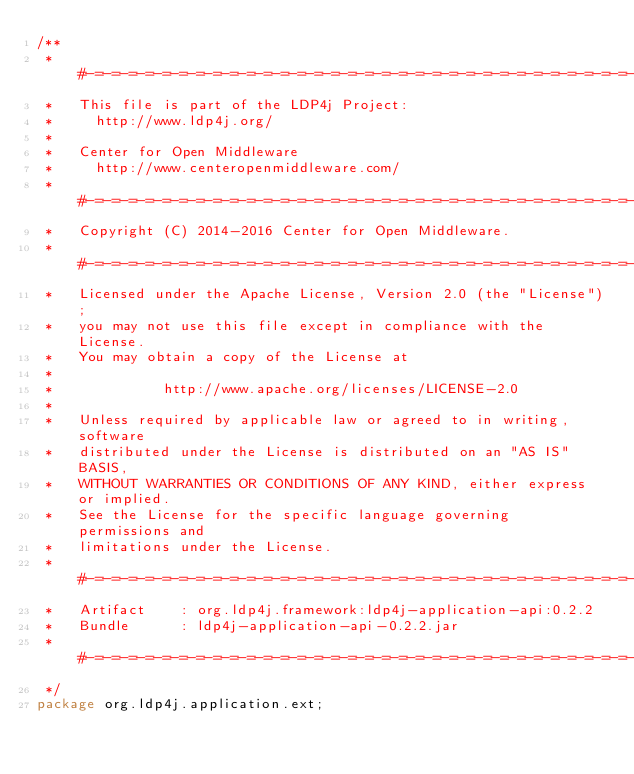Convert code to text. <code><loc_0><loc_0><loc_500><loc_500><_Java_>/**
 * #-=-=-=-=-=-=-=-=-=-=-=-=-=-=-=-=-=-=-=-=-=-=-=-=-=-=-=-=-=-=-=-=-=-=-=-=-=#
 *   This file is part of the LDP4j Project:
 *     http://www.ldp4j.org/
 *
 *   Center for Open Middleware
 *     http://www.centeropenmiddleware.com/
 * #-=-=-=-=-=-=-=-=-=-=-=-=-=-=-=-=-=-=-=-=-=-=-=-=-=-=-=-=-=-=-=-=-=-=-=-=-=#
 *   Copyright (C) 2014-2016 Center for Open Middleware.
 * #-=-=-=-=-=-=-=-=-=-=-=-=-=-=-=-=-=-=-=-=-=-=-=-=-=-=-=-=-=-=-=-=-=-=-=-=-=#
 *   Licensed under the Apache License, Version 2.0 (the "License");
 *   you may not use this file except in compliance with the License.
 *   You may obtain a copy of the License at
 *
 *             http://www.apache.org/licenses/LICENSE-2.0
 *
 *   Unless required by applicable law or agreed to in writing, software
 *   distributed under the License is distributed on an "AS IS" BASIS,
 *   WITHOUT WARRANTIES OR CONDITIONS OF ANY KIND, either express or implied.
 *   See the License for the specific language governing permissions and
 *   limitations under the License.
 * #-=-=-=-=-=-=-=-=-=-=-=-=-=-=-=-=-=-=-=-=-=-=-=-=-=-=-=-=-=-=-=-=-=-=-=-=-=#
 *   Artifact    : org.ldp4j.framework:ldp4j-application-api:0.2.2
 *   Bundle      : ldp4j-application-api-0.2.2.jar
 * #-=-=-=-=-=-=-=-=-=-=-=-=-=-=-=-=-=-=-=-=-=-=-=-=-=-=-=-=-=-=-=-=-=-=-=-=-=#
 */
package org.ldp4j.application.ext;
</code> 